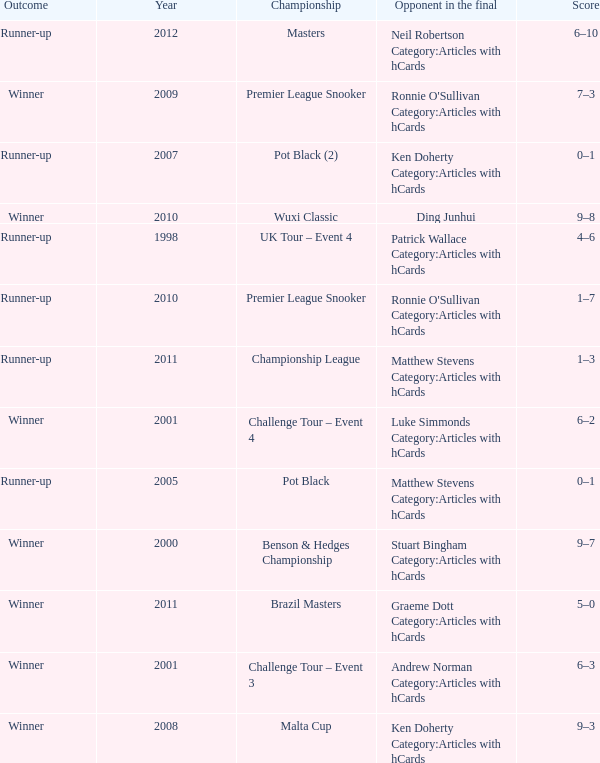What was Shaun Murphy's outcome in the Premier League Snooker championship held before 2010? Winner. 